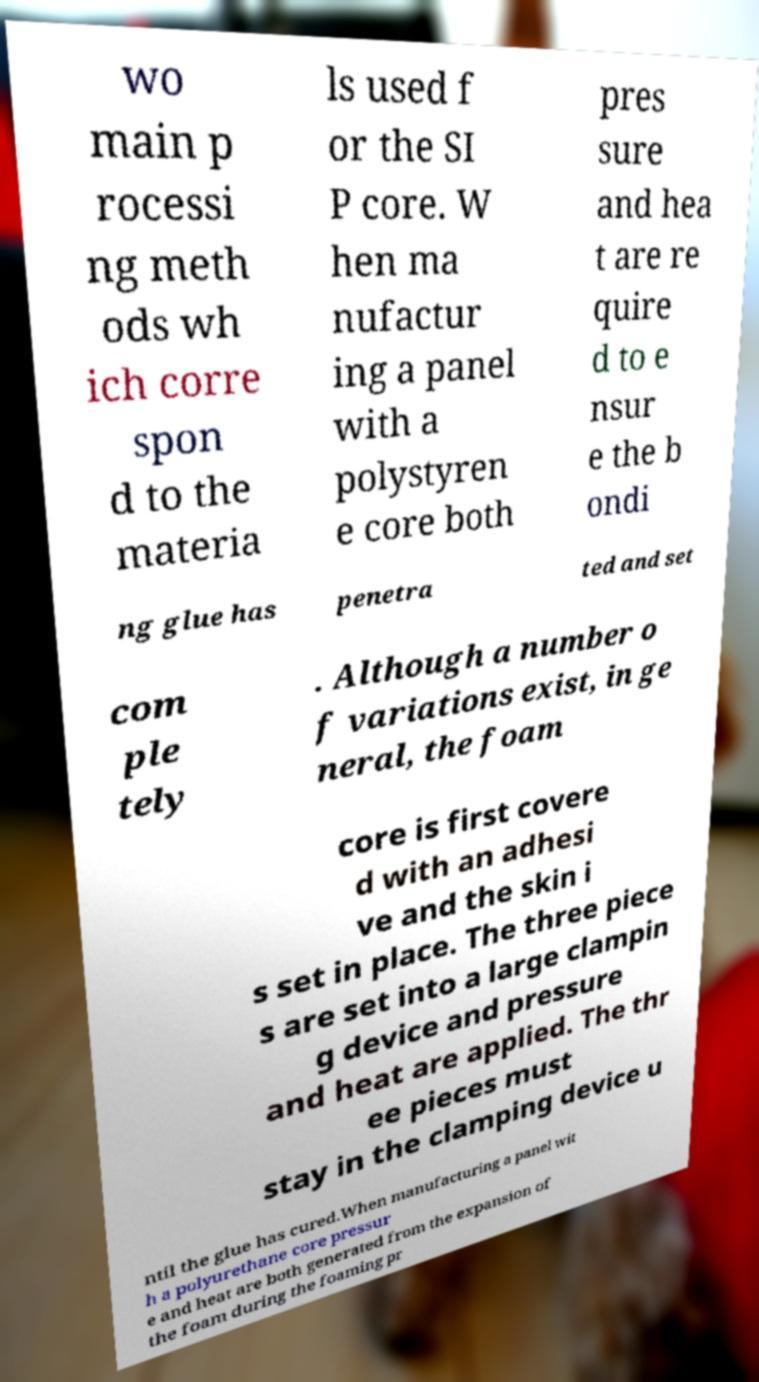I need the written content from this picture converted into text. Can you do that? wo main p rocessi ng meth ods wh ich corre spon d to the materia ls used f or the SI P core. W hen ma nufactur ing a panel with a polystyren e core both pres sure and hea t are re quire d to e nsur e the b ondi ng glue has penetra ted and set com ple tely . Although a number o f variations exist, in ge neral, the foam core is first covere d with an adhesi ve and the skin i s set in place. The three piece s are set into a large clampin g device and pressure and heat are applied. The thr ee pieces must stay in the clamping device u ntil the glue has cured.When manufacturing a panel wit h a polyurethane core pressur e and heat are both generated from the expansion of the foam during the foaming pr 